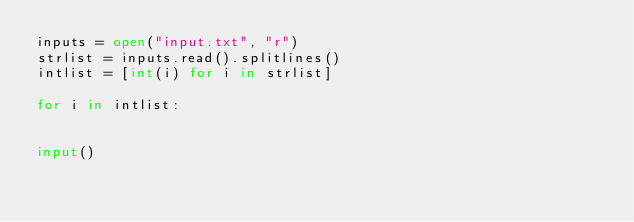<code> <loc_0><loc_0><loc_500><loc_500><_Python_>inputs = open("input.txt", "r")
strlist = inputs.read().splitlines()
intlist = [int(i) for i in strlist]

for i in intlist:
    

input()</code> 